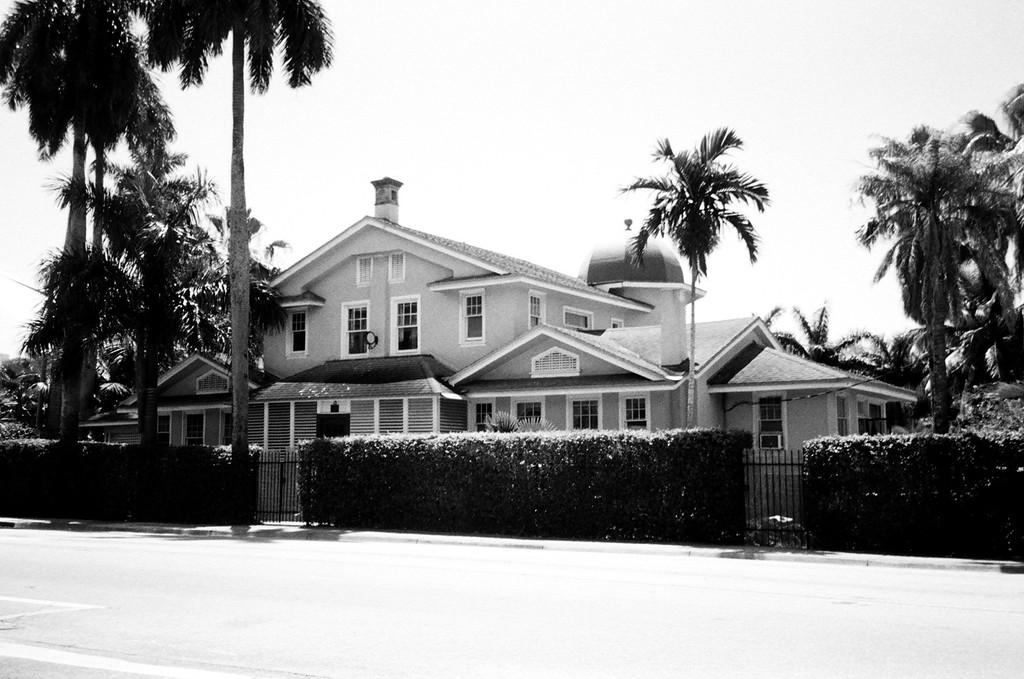What is located at the front of the image? There is a road in the front of the image. What can be seen in the background of the image? There are bushes, two gates, multiple trees, and a building in the background of the image. What is the color scheme of the image? The image is black and white in color. What type of trousers are being worn by the trees in the background? There are no trousers present in the image, as the subjects are trees and not people. What direction is the development facing in the image? The image does not depict any development or construction; it features a road, bushes, gates, trees, and a building. 